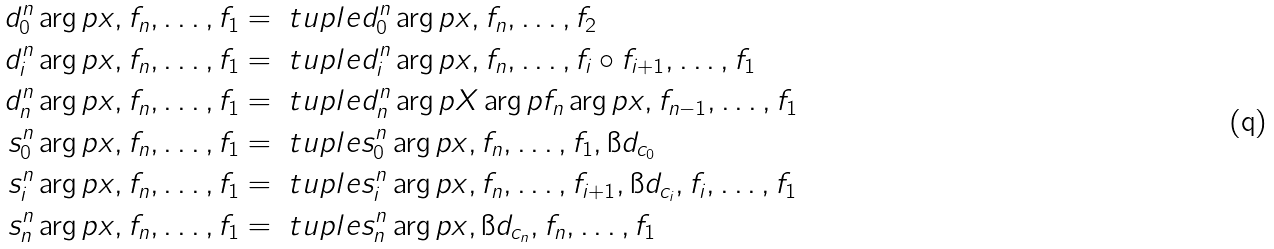Convert formula to latex. <formula><loc_0><loc_0><loc_500><loc_500>d ^ { n } _ { 0 } \arg p { x , f _ { n } , \dots , f _ { 1 } } & = \ t u p l e { d ^ { n } _ { 0 } \arg p { x } , f _ { n } , \dots , f _ { 2 } } \\ d ^ { n } _ { i } \arg p { x , f _ { n } , \dots , f _ { 1 } } & = \ t u p l e { d ^ { n } _ { i } \arg p { x } , f _ { n } , \dots , f _ { i } \circ f _ { i + 1 } , \dots , f _ { 1 } } \\ d ^ { n } _ { n } \arg p { x , f _ { n } , \dots , f _ { 1 } } & = \ t u p l e { d ^ { n } _ { n } \arg p { X \arg p { f _ { n } } \arg p { x } } , f _ { n - 1 } , \dots , f _ { 1 } } \\ s ^ { n } _ { 0 } \arg p { x , f _ { n } , \dots , f _ { 1 } } & = \ t u p l e { s ^ { n } _ { 0 } \arg p { x } , f _ { n } , \dots , f _ { 1 } , \i d _ { c _ { 0 } } } \\ s ^ { n } _ { i } \arg p { x , f _ { n } , \dots , f _ { 1 } } & = \ t u p l e { s ^ { n } _ { i } \arg p { x } , f _ { n } , \dots , f _ { i + 1 } , \i d _ { c _ { i } } , f _ { i } , \dots , f _ { 1 } } \\ s ^ { n } _ { n } \arg p { x , f _ { n } , \dots , f _ { 1 } } & = \ t u p l e { s ^ { n } _ { n } \arg p { x } , \i d _ { c _ { n } } , f _ { n } , \dots , f _ { 1 } }</formula> 